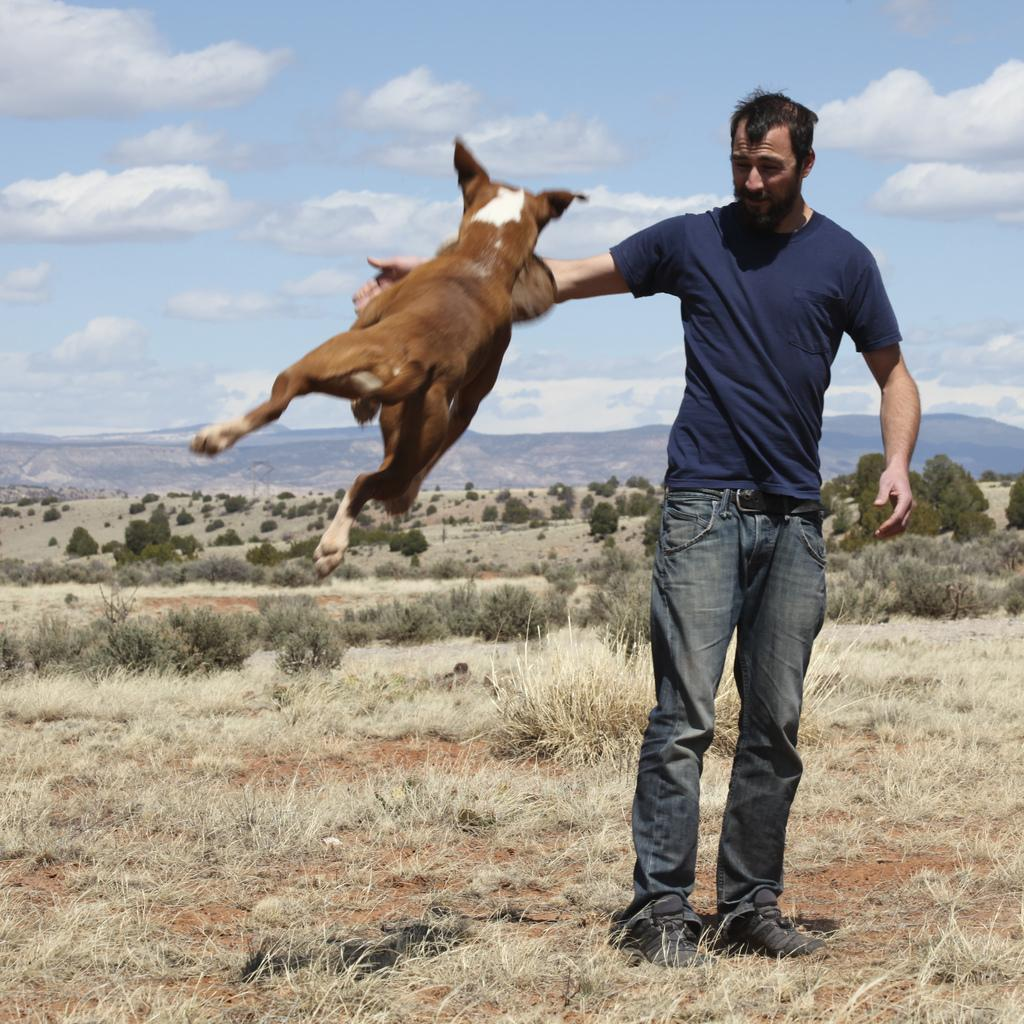What is the main subject in the image? There is a person standing in the image. What is the dog doing in the image? The dog is in the air in the image. What type of natural environment is visible behind the person? There are trees, plants, and mountains visible behind the person. What is visible at the top of the image? The sky is visible at the top of the image. What type of engine can be seen powering the person's movement in the image? There is no engine present in the image, and the person's movement is not powered by any visible engine. 